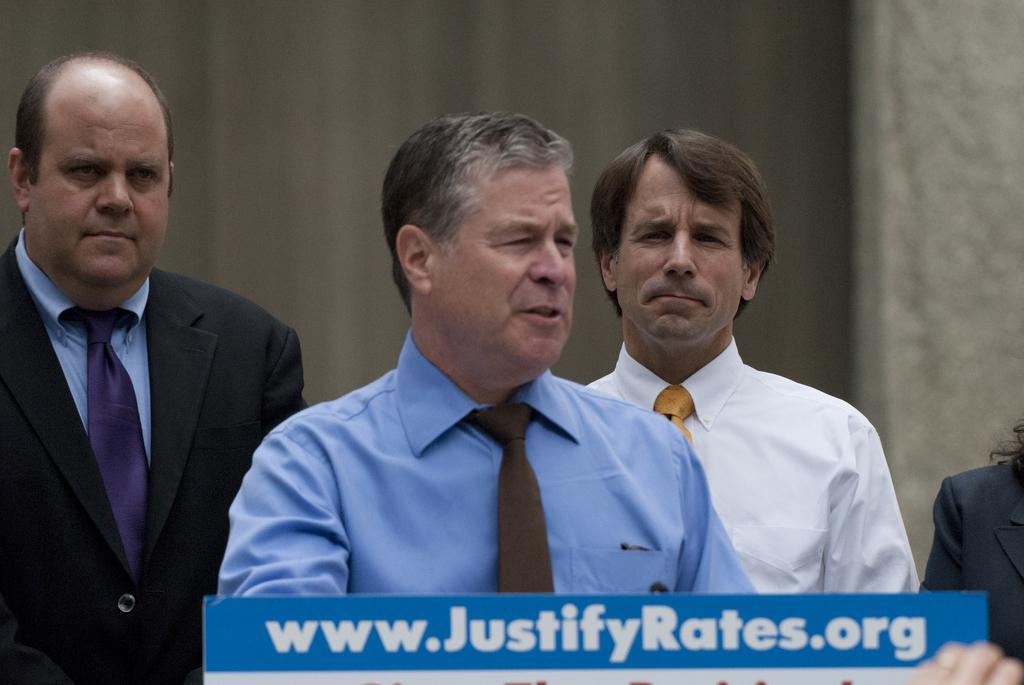How many people are in the image? There are four persons standing in the image. What is in front of the people? There is a cardboard in front of them. Is there any text or image on the cardboard? Yes, something is written on the cardboard. Can you see any deer grazing in the background of the image? There are no deer present in the image. What type of fruit is being held by the persons in the image? The image does not show any fruit being held by the persons. 